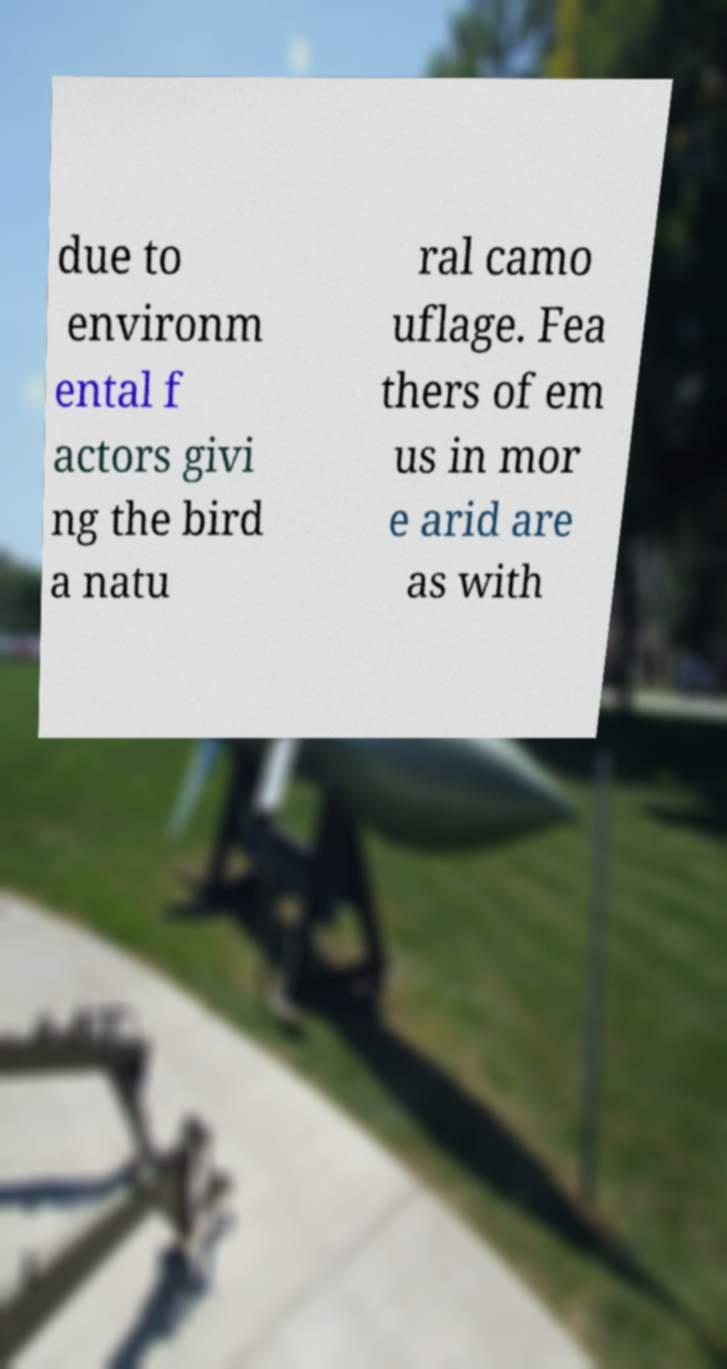There's text embedded in this image that I need extracted. Can you transcribe it verbatim? due to environm ental f actors givi ng the bird a natu ral camo uflage. Fea thers of em us in mor e arid are as with 